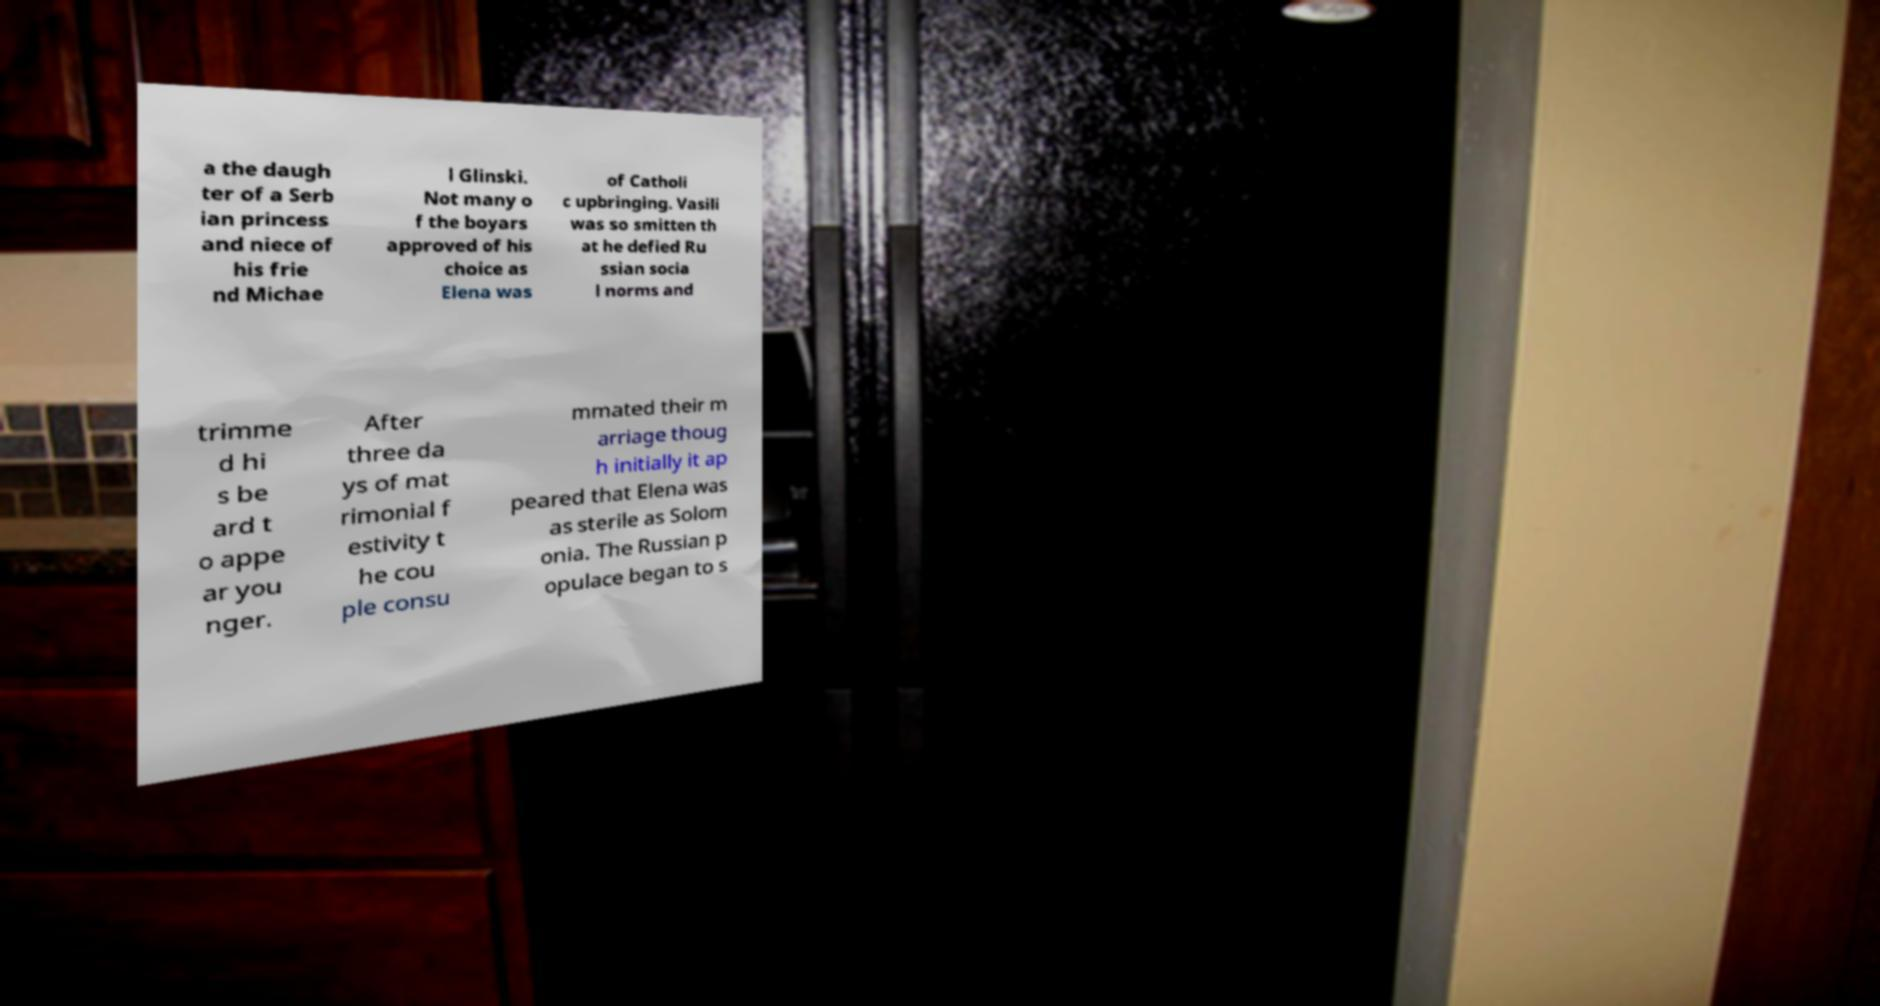Please identify and transcribe the text found in this image. a the daugh ter of a Serb ian princess and niece of his frie nd Michae l Glinski. Not many o f the boyars approved of his choice as Elena was of Catholi c upbringing. Vasili was so smitten th at he defied Ru ssian socia l norms and trimme d hi s be ard t o appe ar you nger. After three da ys of mat rimonial f estivity t he cou ple consu mmated their m arriage thoug h initially it ap peared that Elena was as sterile as Solom onia. The Russian p opulace began to s 